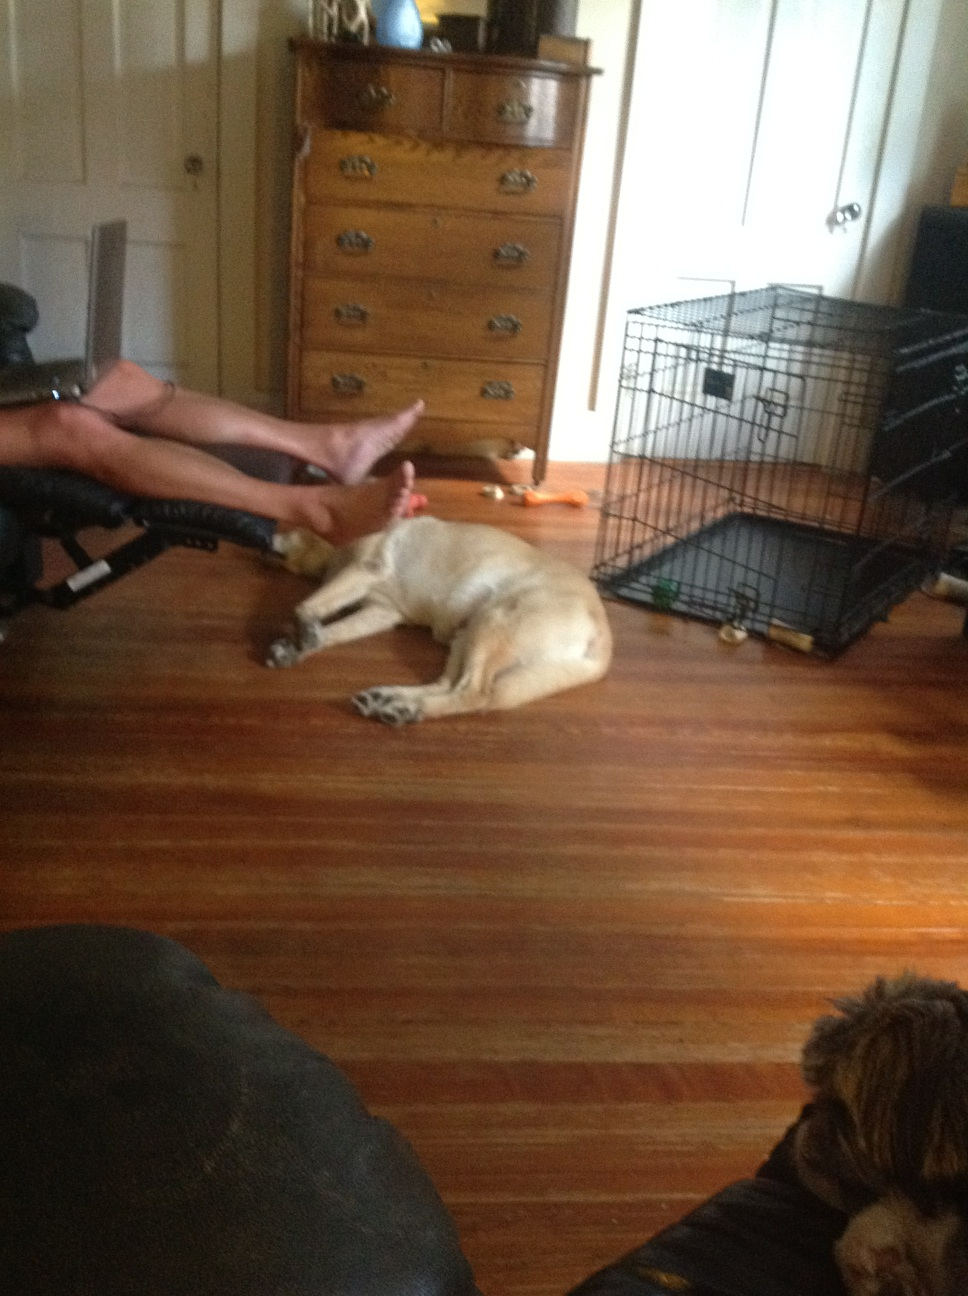What is on the floor? On the floor, there appears to be a dog lying down comfortably, resting with its head and legs extended. The floor itself is wooden, and in the background, another dog can be partially seen sitting near a black chair, with a metal pet crate and a wooden chest of drawers also visible in the room. 